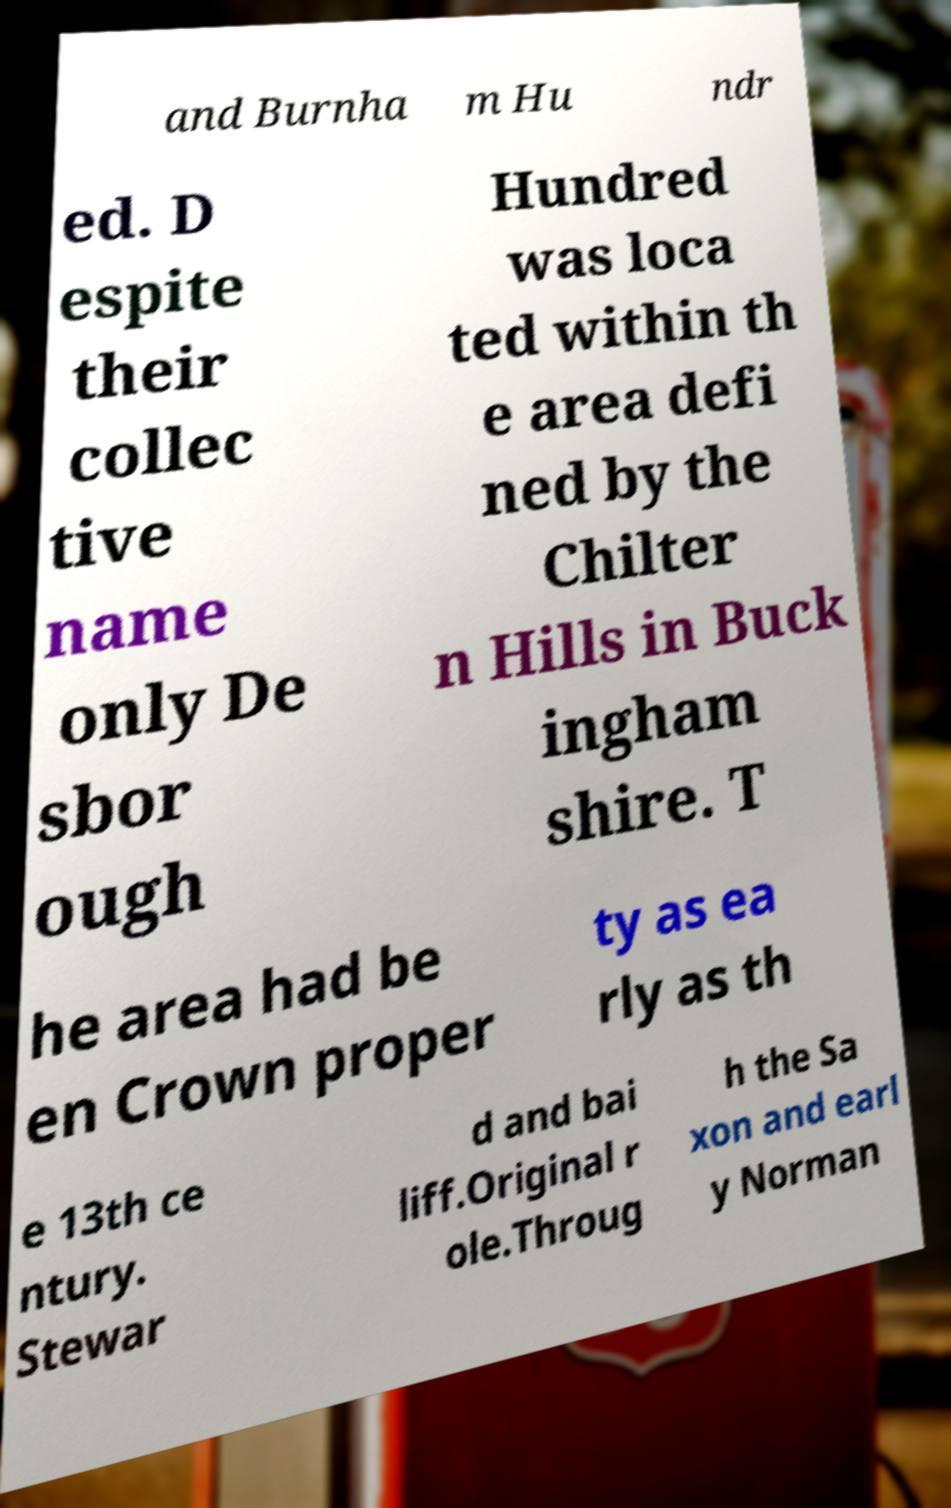For documentation purposes, I need the text within this image transcribed. Could you provide that? and Burnha m Hu ndr ed. D espite their collec tive name only De sbor ough Hundred was loca ted within th e area defi ned by the Chilter n Hills in Buck ingham shire. T he area had be en Crown proper ty as ea rly as th e 13th ce ntury. Stewar d and bai liff.Original r ole.Throug h the Sa xon and earl y Norman 